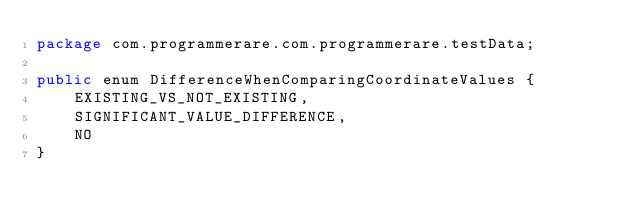Convert code to text. <code><loc_0><loc_0><loc_500><loc_500><_Java_>package com.programmerare.com.programmerare.testData;

public enum DifferenceWhenComparingCoordinateValues {
    EXISTING_VS_NOT_EXISTING,
    SIGNIFICANT_VALUE_DIFFERENCE,
    NO
}
</code> 